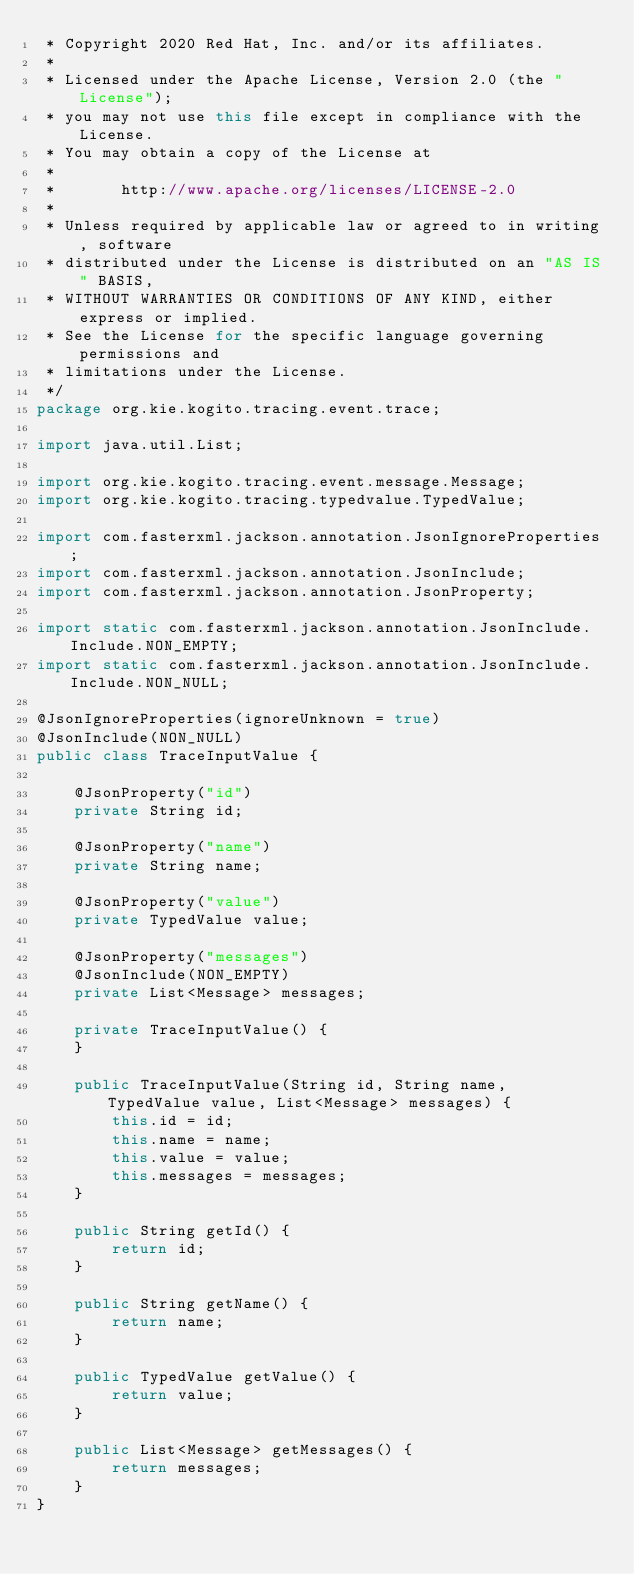Convert code to text. <code><loc_0><loc_0><loc_500><loc_500><_Java_> * Copyright 2020 Red Hat, Inc. and/or its affiliates.
 *
 * Licensed under the Apache License, Version 2.0 (the "License");
 * you may not use this file except in compliance with the License.
 * You may obtain a copy of the License at
 *
 *       http://www.apache.org/licenses/LICENSE-2.0
 *
 * Unless required by applicable law or agreed to in writing, software
 * distributed under the License is distributed on an "AS IS" BASIS,
 * WITHOUT WARRANTIES OR CONDITIONS OF ANY KIND, either express or implied.
 * See the License for the specific language governing permissions and
 * limitations under the License.
 */
package org.kie.kogito.tracing.event.trace;

import java.util.List;

import org.kie.kogito.tracing.event.message.Message;
import org.kie.kogito.tracing.typedvalue.TypedValue;

import com.fasterxml.jackson.annotation.JsonIgnoreProperties;
import com.fasterxml.jackson.annotation.JsonInclude;
import com.fasterxml.jackson.annotation.JsonProperty;

import static com.fasterxml.jackson.annotation.JsonInclude.Include.NON_EMPTY;
import static com.fasterxml.jackson.annotation.JsonInclude.Include.NON_NULL;

@JsonIgnoreProperties(ignoreUnknown = true)
@JsonInclude(NON_NULL)
public class TraceInputValue {

    @JsonProperty("id")
    private String id;

    @JsonProperty("name")
    private String name;

    @JsonProperty("value")
    private TypedValue value;

    @JsonProperty("messages")
    @JsonInclude(NON_EMPTY)
    private List<Message> messages;

    private TraceInputValue() {
    }

    public TraceInputValue(String id, String name, TypedValue value, List<Message> messages) {
        this.id = id;
        this.name = name;
        this.value = value;
        this.messages = messages;
    }

    public String getId() {
        return id;
    }

    public String getName() {
        return name;
    }

    public TypedValue getValue() {
        return value;
    }

    public List<Message> getMessages() {
        return messages;
    }
}
</code> 